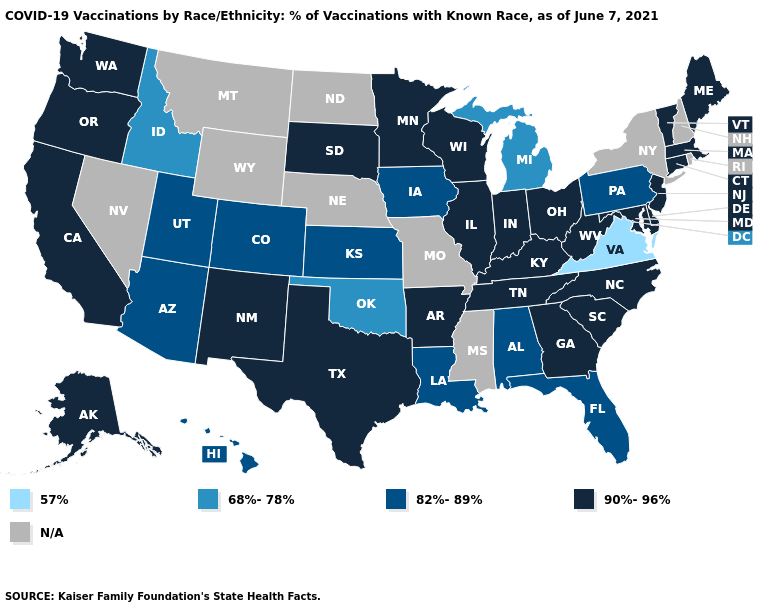Which states hav the highest value in the South?
Concise answer only. Arkansas, Delaware, Georgia, Kentucky, Maryland, North Carolina, South Carolina, Tennessee, Texas, West Virginia. Does the first symbol in the legend represent the smallest category?
Quick response, please. Yes. What is the value of Kansas?
Concise answer only. 82%-89%. Does the map have missing data?
Quick response, please. Yes. Which states hav the highest value in the South?
Be succinct. Arkansas, Delaware, Georgia, Kentucky, Maryland, North Carolina, South Carolina, Tennessee, Texas, West Virginia. What is the highest value in the South ?
Write a very short answer. 90%-96%. Does California have the lowest value in the West?
Keep it brief. No. Which states have the lowest value in the USA?
Be succinct. Virginia. Does Vermont have the highest value in the Northeast?
Be succinct. Yes. What is the value of West Virginia?
Short answer required. 90%-96%. Among the states that border Oklahoma , does New Mexico have the lowest value?
Be succinct. No. Name the states that have a value in the range 90%-96%?
Write a very short answer. Alaska, Arkansas, California, Connecticut, Delaware, Georgia, Illinois, Indiana, Kentucky, Maine, Maryland, Massachusetts, Minnesota, New Jersey, New Mexico, North Carolina, Ohio, Oregon, South Carolina, South Dakota, Tennessee, Texas, Vermont, Washington, West Virginia, Wisconsin. Name the states that have a value in the range N/A?
Be succinct. Mississippi, Missouri, Montana, Nebraska, Nevada, New Hampshire, New York, North Dakota, Rhode Island, Wyoming. 